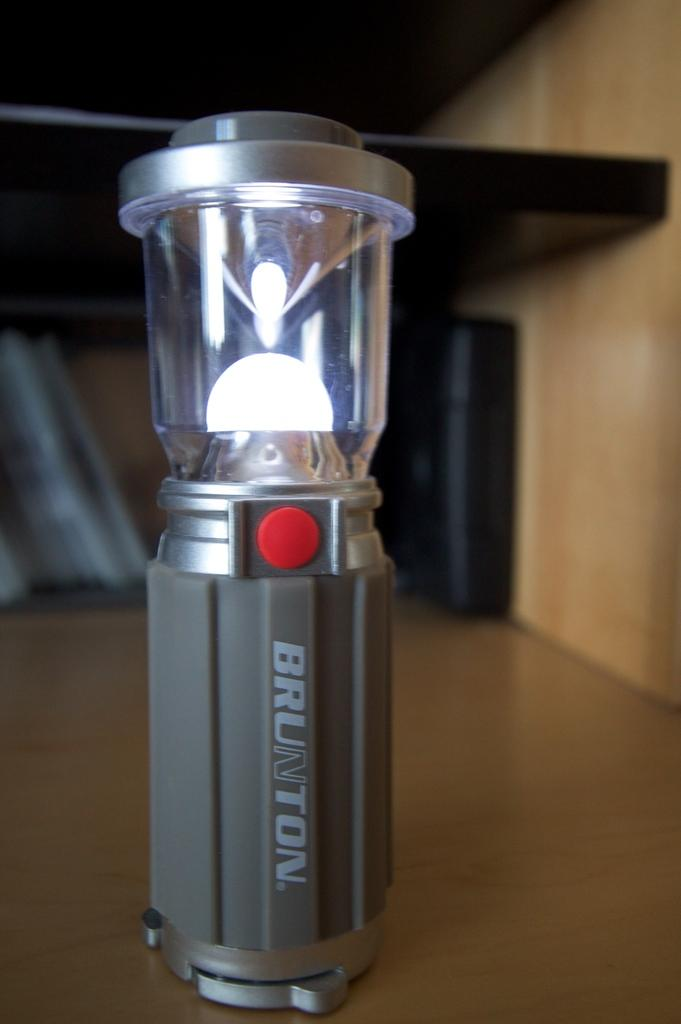<image>
Create a compact narrative representing the image presented. Brunton light that is gray and silver with a red button 